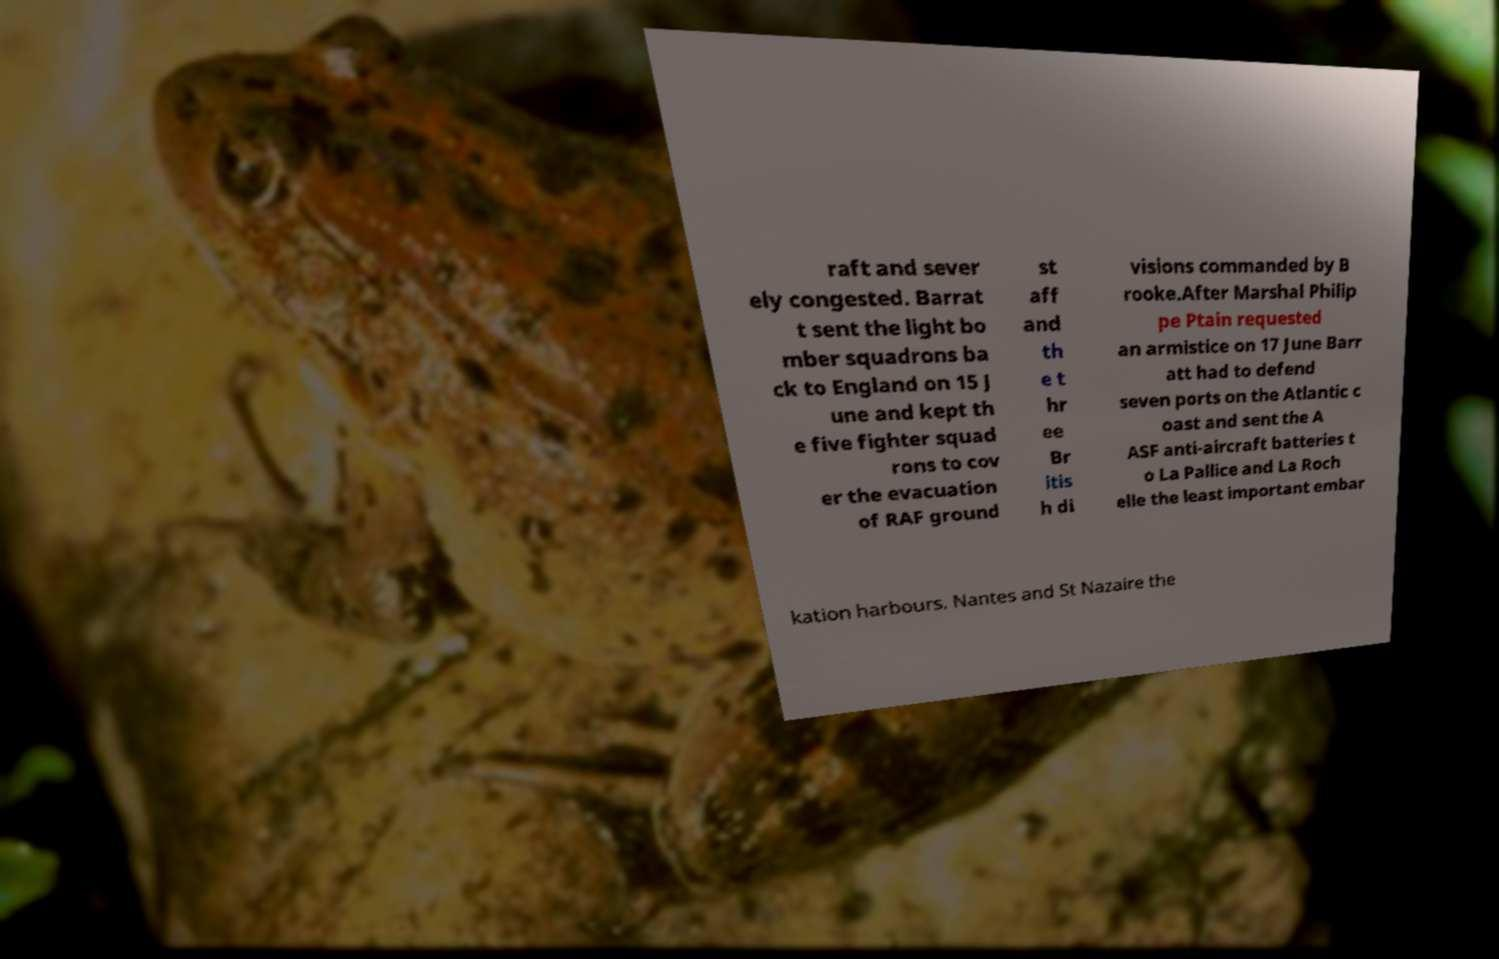There's text embedded in this image that I need extracted. Can you transcribe it verbatim? raft and sever ely congested. Barrat t sent the light bo mber squadrons ba ck to England on 15 J une and kept th e five fighter squad rons to cov er the evacuation of RAF ground st aff and th e t hr ee Br itis h di visions commanded by B rooke.After Marshal Philip pe Ptain requested an armistice on 17 June Barr att had to defend seven ports on the Atlantic c oast and sent the A ASF anti-aircraft batteries t o La Pallice and La Roch elle the least important embar kation harbours. Nantes and St Nazaire the 